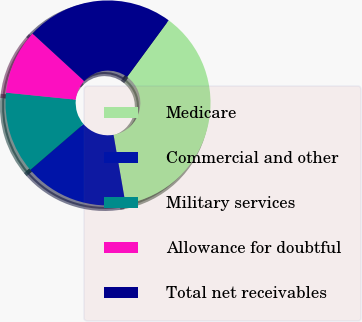Convert chart to OTSL. <chart><loc_0><loc_0><loc_500><loc_500><pie_chart><fcel>Medicare<fcel>Commercial and other<fcel>Military services<fcel>Allowance for doubtful<fcel>Total net receivables<nl><fcel>37.19%<fcel>16.42%<fcel>12.92%<fcel>10.23%<fcel>23.24%<nl></chart> 